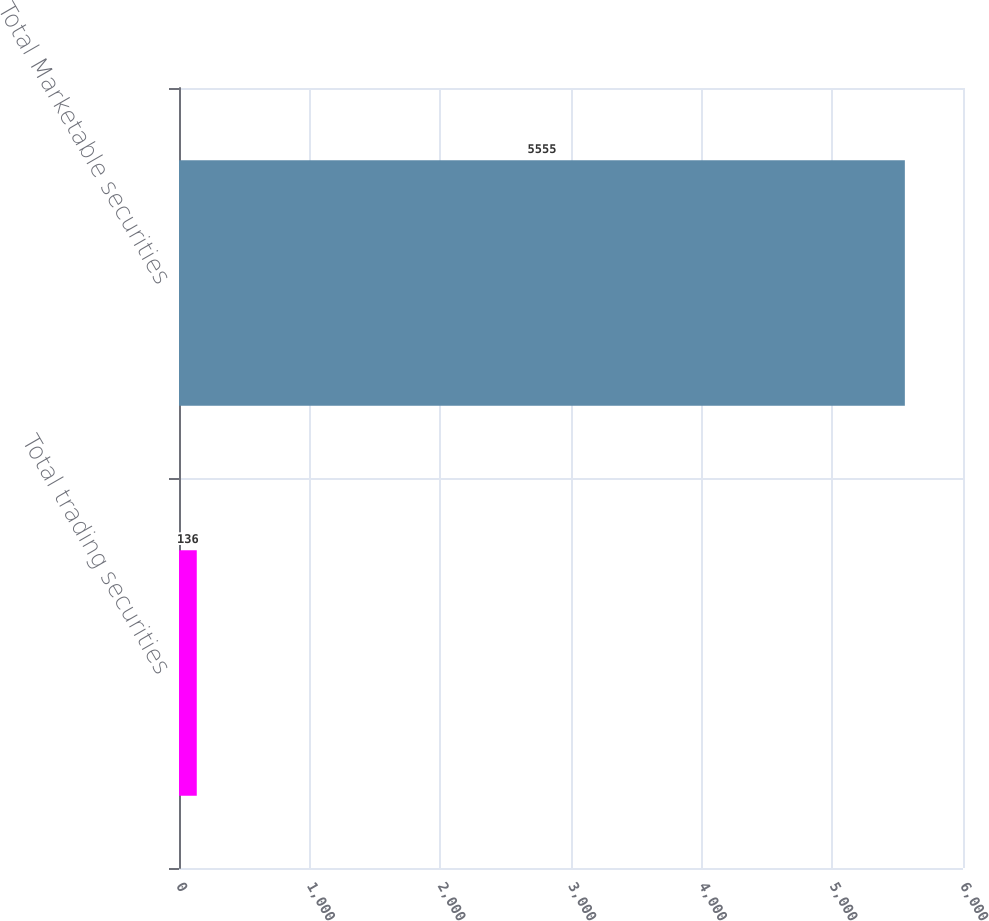Convert chart to OTSL. <chart><loc_0><loc_0><loc_500><loc_500><bar_chart><fcel>Total trading securities<fcel>Total Marketable securities<nl><fcel>136<fcel>5555<nl></chart> 